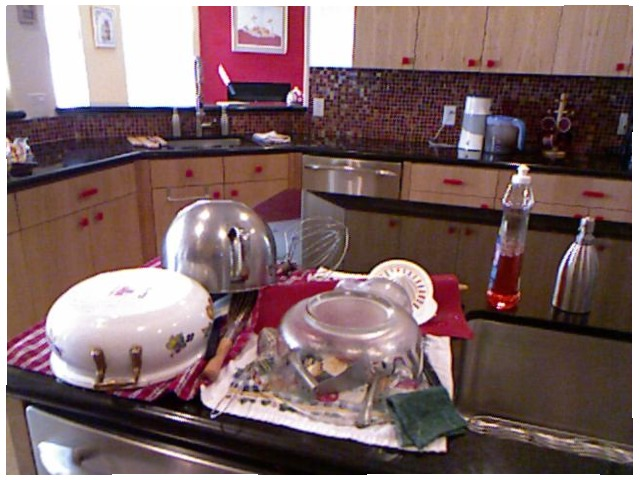<image>
Can you confirm if the dish soap is on the counter? Yes. Looking at the image, I can see the dish soap is positioned on top of the counter, with the counter providing support. 